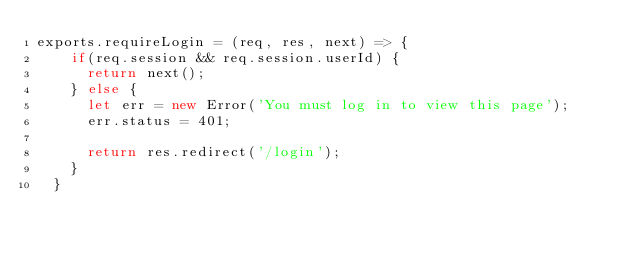<code> <loc_0><loc_0><loc_500><loc_500><_JavaScript_>exports.requireLogin = (req, res, next) => {
    if(req.session && req.session.userId) {
      return next();
    } else {
      let err = new Error('You must log in to view this page');
      err.status = 401;
  
      return res.redirect('/login');
    }
  }</code> 